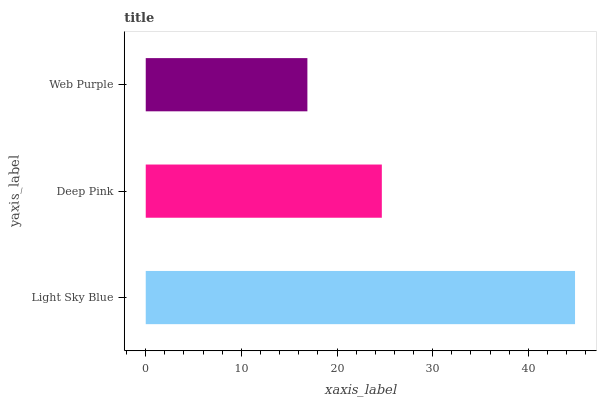Is Web Purple the minimum?
Answer yes or no. Yes. Is Light Sky Blue the maximum?
Answer yes or no. Yes. Is Deep Pink the minimum?
Answer yes or no. No. Is Deep Pink the maximum?
Answer yes or no. No. Is Light Sky Blue greater than Deep Pink?
Answer yes or no. Yes. Is Deep Pink less than Light Sky Blue?
Answer yes or no. Yes. Is Deep Pink greater than Light Sky Blue?
Answer yes or no. No. Is Light Sky Blue less than Deep Pink?
Answer yes or no. No. Is Deep Pink the high median?
Answer yes or no. Yes. Is Deep Pink the low median?
Answer yes or no. Yes. Is Light Sky Blue the high median?
Answer yes or no. No. Is Light Sky Blue the low median?
Answer yes or no. No. 